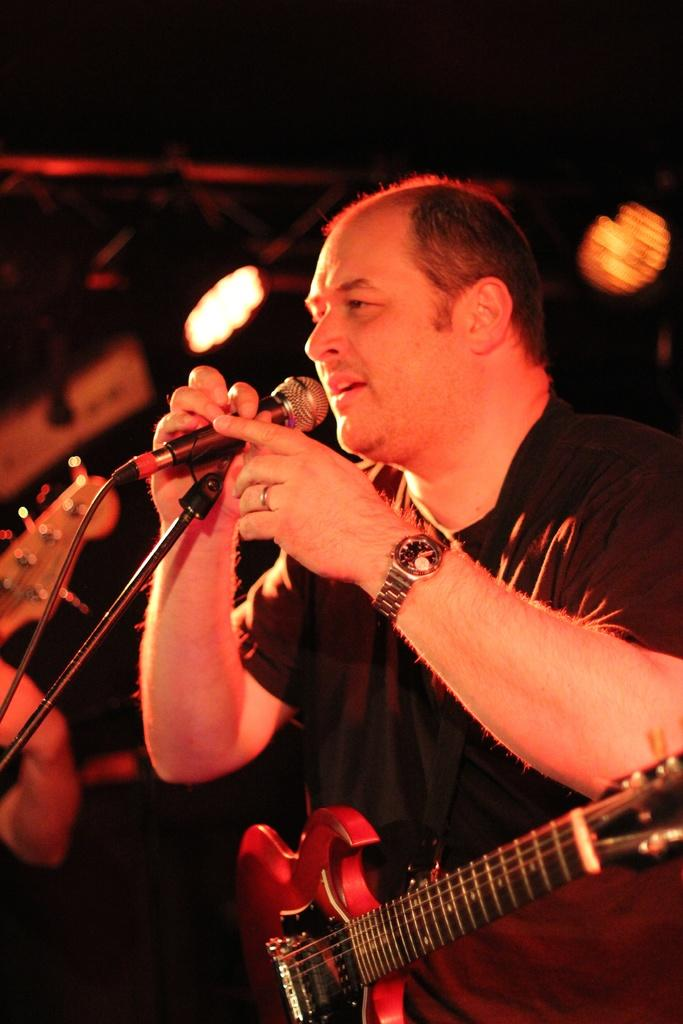What is the person in the image wearing? The person is wearing a guitar in the image. What is the person holding in the image? The person is holding a microphone. Can you describe anything to the left of the person? There is a person's hand visible to the left. What can be seen in the background of the image? There are lights in the background of the image. What type of clam is being used as a prop in the image? There is no clam present in the image. What place is the person performing at in the image? The image does not provide information about the location or place where the person is performing. 